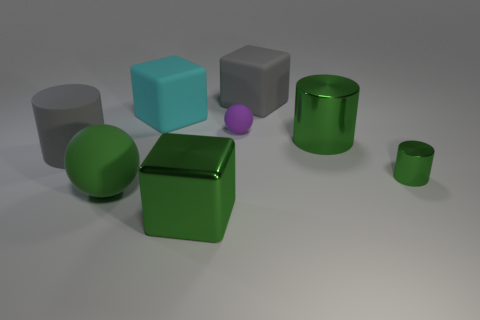How many blocks are the same color as the rubber cylinder?
Give a very brief answer. 1. There is a purple object that is made of the same material as the big ball; what is its size?
Your response must be concise. Small. How many things are large cylinders that are on the right side of the big sphere or large yellow things?
Keep it short and to the point. 1. Does the large matte thing that is on the right side of the cyan matte thing have the same color as the matte cylinder?
Offer a terse response. Yes. What size is the purple matte thing that is the same shape as the green rubber object?
Give a very brief answer. Small. What is the color of the big cylinder on the right side of the gray object that is behind the large matte block in front of the large gray matte cube?
Offer a very short reply. Green. Is the material of the cyan object the same as the small ball?
Make the answer very short. Yes. Is there a large shiny cylinder that is left of the rubber block that is on the right side of the ball that is right of the green cube?
Keep it short and to the point. No. Does the small metal thing have the same color as the big metal cube?
Your response must be concise. Yes. Are there fewer large green things than tiny matte objects?
Offer a terse response. No. 